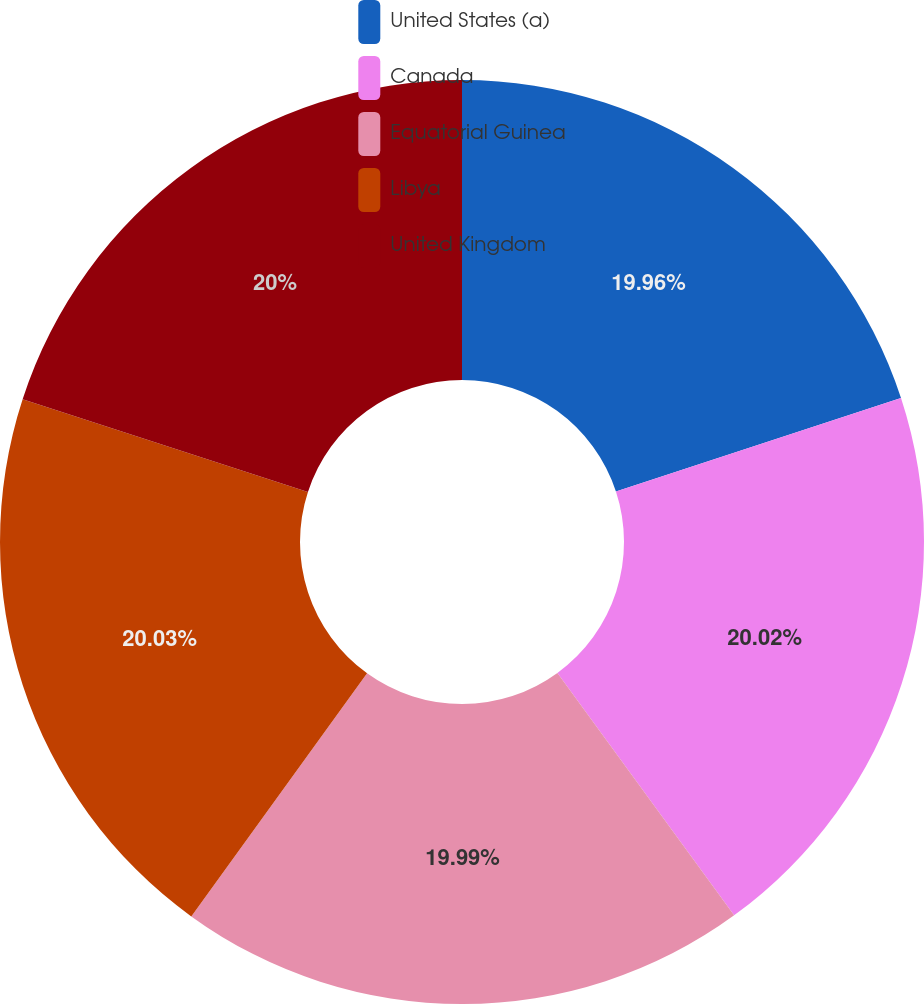Convert chart. <chart><loc_0><loc_0><loc_500><loc_500><pie_chart><fcel>United States (a)<fcel>Canada<fcel>Equatorial Guinea<fcel>Libya<fcel>United Kingdom<nl><fcel>19.96%<fcel>20.02%<fcel>19.99%<fcel>20.04%<fcel>20.0%<nl></chart> 